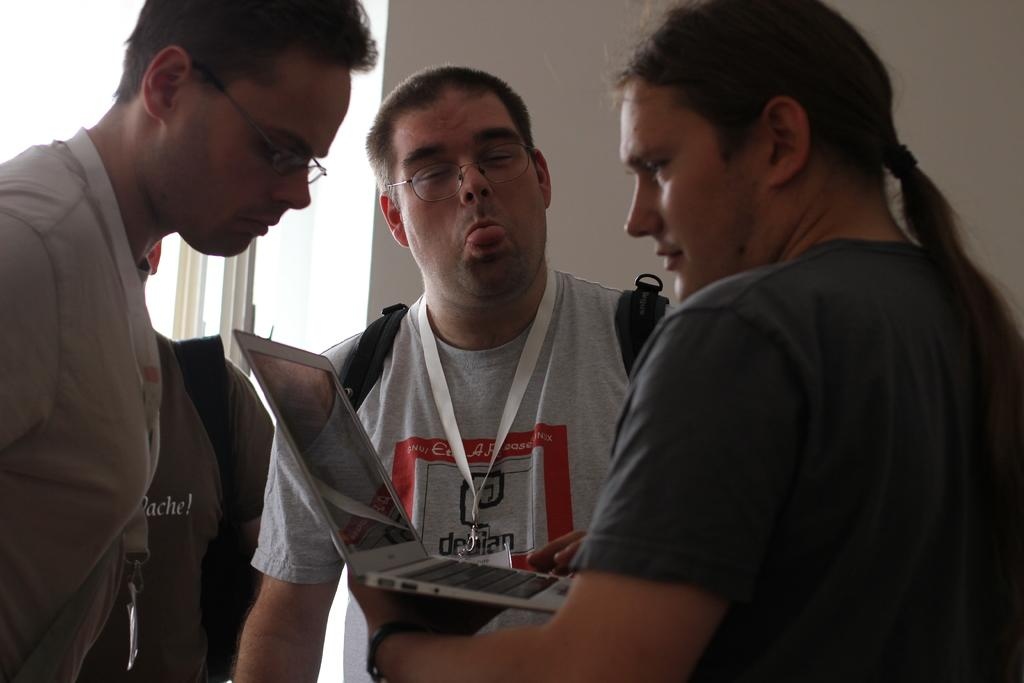How many people are in the image? There are people in the image, but the exact number is not specified. What are the people wearing? The people are wearing clothes. Can you describe any accessories the people are wearing? Two people are wearing spectacles. What items do two of the people have that might be used for identification? Two people have identity cards. What electronic device is visible in the image? There is a laptop in the image. Can you describe any hair accessory in the image? There is a hairband in the image. What type of bag is present in the image? There is a bag in the image. What type of structure is visible in the background? There is a wall in the image. What type of truck is parked next to the wall in the image? There is no truck present in the image; only a wall is mentioned. Can you describe the owner of the laptop in the image? There is no information about the owner of the laptop in the image. How many frogs can be seen in the image? There are no frogs present in the image. 